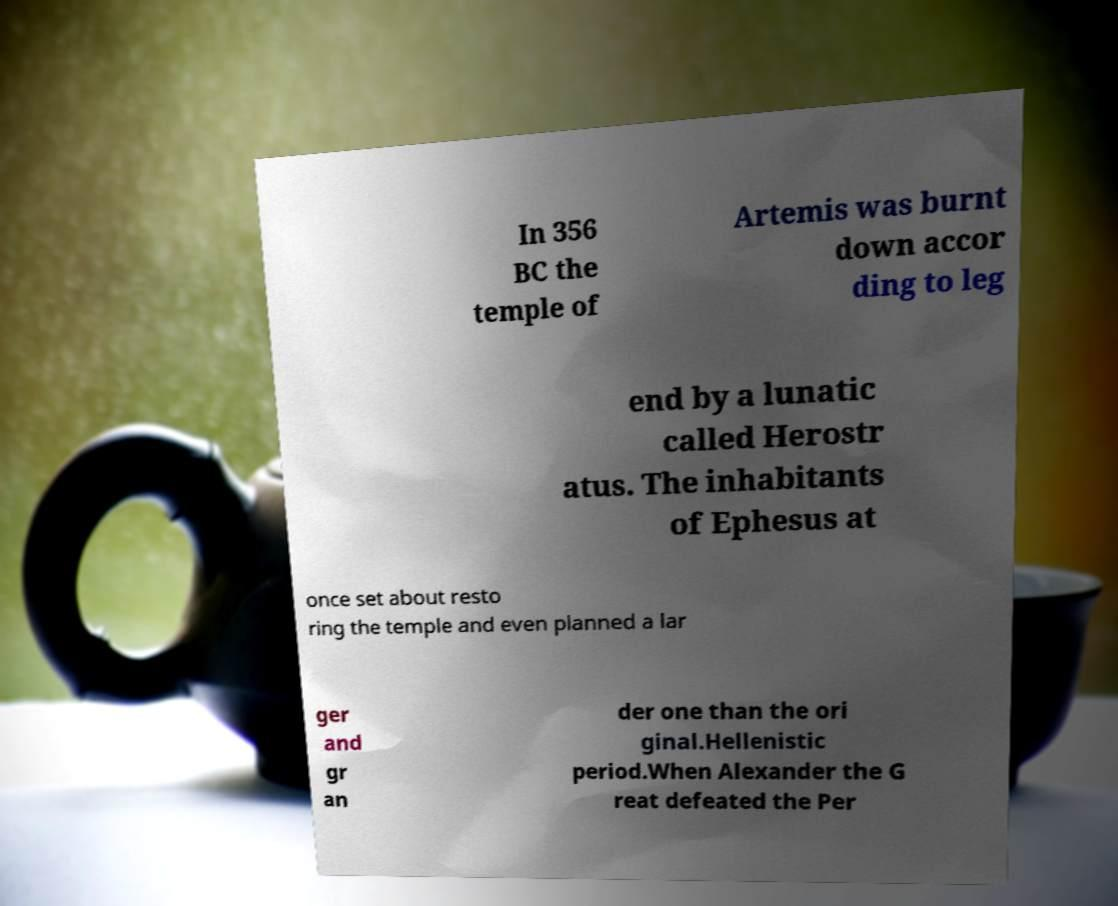I need the written content from this picture converted into text. Can you do that? In 356 BC the temple of Artemis was burnt down accor ding to leg end by a lunatic called Herostr atus. The inhabitants of Ephesus at once set about resto ring the temple and even planned a lar ger and gr an der one than the ori ginal.Hellenistic period.When Alexander the G reat defeated the Per 